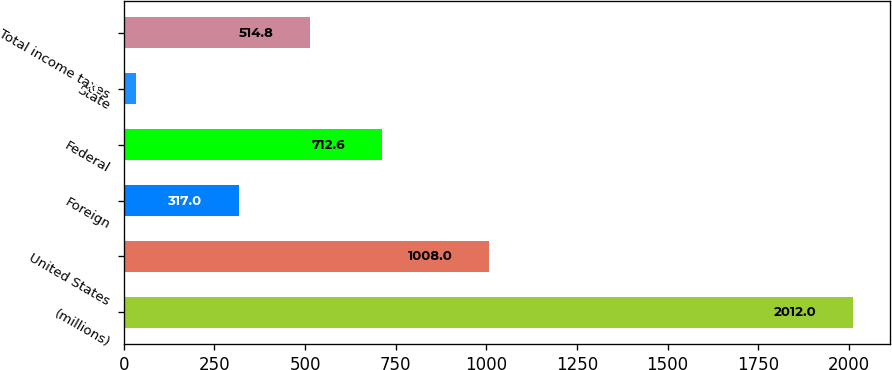<chart> <loc_0><loc_0><loc_500><loc_500><bar_chart><fcel>(millions)<fcel>United States<fcel>Foreign<fcel>Federal<fcel>State<fcel>Total income taxes<nl><fcel>2012<fcel>1008<fcel>317<fcel>712.6<fcel>34<fcel>514.8<nl></chart> 